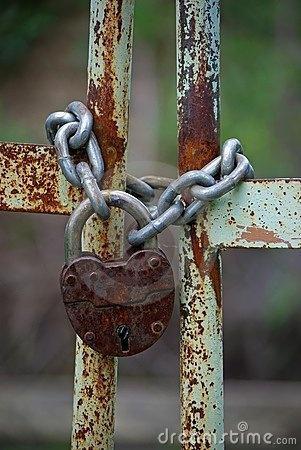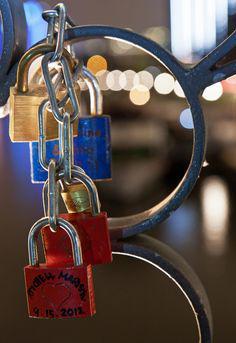The first image is the image on the left, the second image is the image on the right. Considering the images on both sides, is "An image shows a rusty brownish chain attached to at least one lock, in front of brownish bars." valid? Answer yes or no. No. The first image is the image on the left, the second image is the image on the right. Analyze the images presented: Is the assertion "A lock is hanging on a chain in the image on the left." valid? Answer yes or no. Yes. 